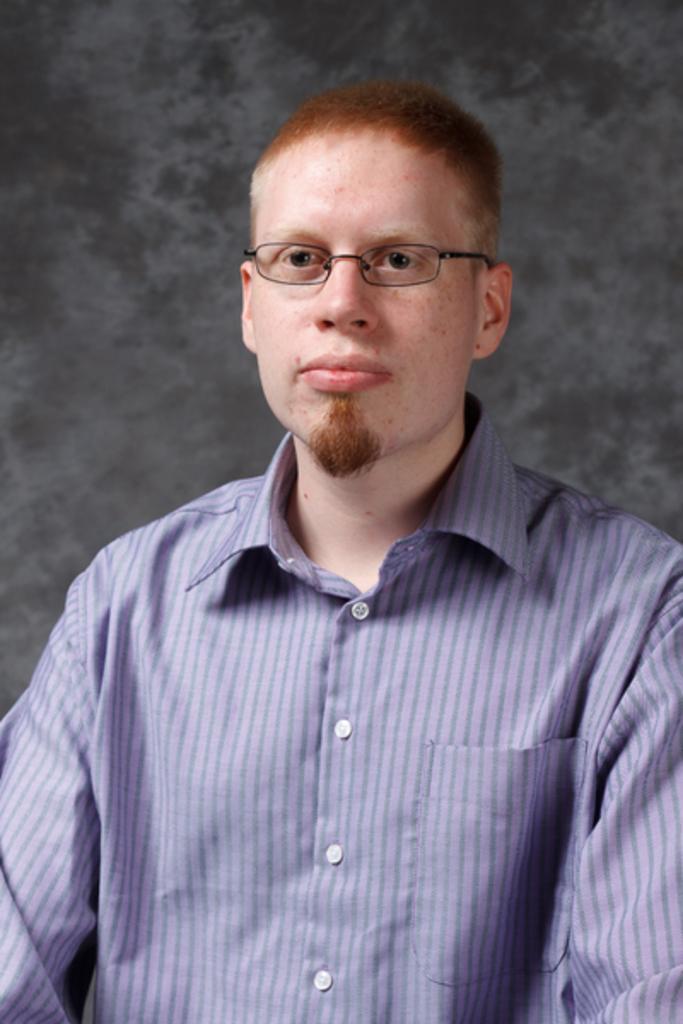How would you summarize this image in a sentence or two? In this image, we can see a man wearing a blue color shirt. In the background, we can see black color. 